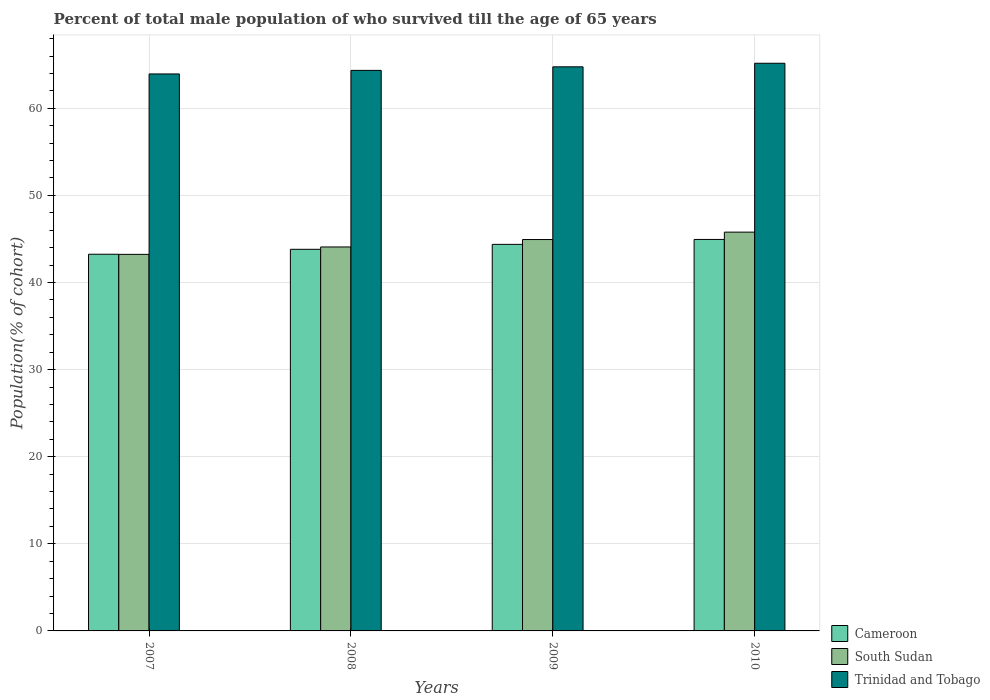Are the number of bars per tick equal to the number of legend labels?
Offer a very short reply. Yes. How many bars are there on the 1st tick from the left?
Offer a very short reply. 3. How many bars are there on the 2nd tick from the right?
Ensure brevity in your answer.  3. What is the label of the 4th group of bars from the left?
Your answer should be compact. 2010. What is the percentage of total male population who survived till the age of 65 years in Cameroon in 2008?
Give a very brief answer. 43.81. Across all years, what is the maximum percentage of total male population who survived till the age of 65 years in South Sudan?
Offer a terse response. 45.78. Across all years, what is the minimum percentage of total male population who survived till the age of 65 years in Cameroon?
Your answer should be very brief. 43.24. In which year was the percentage of total male population who survived till the age of 65 years in Cameroon minimum?
Ensure brevity in your answer.  2007. What is the total percentage of total male population who survived till the age of 65 years in Cameroon in the graph?
Provide a short and direct response. 176.38. What is the difference between the percentage of total male population who survived till the age of 65 years in South Sudan in 2007 and that in 2008?
Provide a succinct answer. -0.85. What is the difference between the percentage of total male population who survived till the age of 65 years in South Sudan in 2008 and the percentage of total male population who survived till the age of 65 years in Cameroon in 2010?
Provide a short and direct response. -0.86. What is the average percentage of total male population who survived till the age of 65 years in Trinidad and Tobago per year?
Your response must be concise. 64.56. In the year 2007, what is the difference between the percentage of total male population who survived till the age of 65 years in Cameroon and percentage of total male population who survived till the age of 65 years in South Sudan?
Offer a very short reply. 0.02. In how many years, is the percentage of total male population who survived till the age of 65 years in South Sudan greater than 36 %?
Ensure brevity in your answer.  4. What is the ratio of the percentage of total male population who survived till the age of 65 years in Trinidad and Tobago in 2008 to that in 2009?
Ensure brevity in your answer.  0.99. Is the difference between the percentage of total male population who survived till the age of 65 years in Cameroon in 2007 and 2008 greater than the difference between the percentage of total male population who survived till the age of 65 years in South Sudan in 2007 and 2008?
Keep it short and to the point. Yes. What is the difference between the highest and the second highest percentage of total male population who survived till the age of 65 years in Cameroon?
Provide a short and direct response. 0.57. What is the difference between the highest and the lowest percentage of total male population who survived till the age of 65 years in Cameroon?
Your answer should be very brief. 1.7. Is the sum of the percentage of total male population who survived till the age of 65 years in Trinidad and Tobago in 2009 and 2010 greater than the maximum percentage of total male population who survived till the age of 65 years in Cameroon across all years?
Make the answer very short. Yes. What does the 3rd bar from the left in 2008 represents?
Keep it short and to the point. Trinidad and Tobago. What does the 1st bar from the right in 2008 represents?
Offer a very short reply. Trinidad and Tobago. Is it the case that in every year, the sum of the percentage of total male population who survived till the age of 65 years in South Sudan and percentage of total male population who survived till the age of 65 years in Trinidad and Tobago is greater than the percentage of total male population who survived till the age of 65 years in Cameroon?
Ensure brevity in your answer.  Yes. How many bars are there?
Make the answer very short. 12. How are the legend labels stacked?
Your answer should be very brief. Vertical. What is the title of the graph?
Ensure brevity in your answer.  Percent of total male population of who survived till the age of 65 years. Does "Panama" appear as one of the legend labels in the graph?
Your response must be concise. No. What is the label or title of the Y-axis?
Offer a very short reply. Population(% of cohort). What is the Population(% of cohort) in Cameroon in 2007?
Provide a short and direct response. 43.24. What is the Population(% of cohort) of South Sudan in 2007?
Provide a short and direct response. 43.23. What is the Population(% of cohort) in Trinidad and Tobago in 2007?
Your answer should be very brief. 63.94. What is the Population(% of cohort) in Cameroon in 2008?
Provide a succinct answer. 43.81. What is the Population(% of cohort) in South Sudan in 2008?
Keep it short and to the point. 44.08. What is the Population(% of cohort) in Trinidad and Tobago in 2008?
Keep it short and to the point. 64.35. What is the Population(% of cohort) in Cameroon in 2009?
Provide a succinct answer. 44.38. What is the Population(% of cohort) of South Sudan in 2009?
Offer a very short reply. 44.93. What is the Population(% of cohort) of Trinidad and Tobago in 2009?
Provide a succinct answer. 64.76. What is the Population(% of cohort) of Cameroon in 2010?
Offer a very short reply. 44.94. What is the Population(% of cohort) of South Sudan in 2010?
Offer a very short reply. 45.78. What is the Population(% of cohort) in Trinidad and Tobago in 2010?
Make the answer very short. 65.17. Across all years, what is the maximum Population(% of cohort) of Cameroon?
Your answer should be compact. 44.94. Across all years, what is the maximum Population(% of cohort) of South Sudan?
Your answer should be very brief. 45.78. Across all years, what is the maximum Population(% of cohort) of Trinidad and Tobago?
Your answer should be very brief. 65.17. Across all years, what is the minimum Population(% of cohort) in Cameroon?
Offer a terse response. 43.24. Across all years, what is the minimum Population(% of cohort) in South Sudan?
Make the answer very short. 43.23. Across all years, what is the minimum Population(% of cohort) in Trinidad and Tobago?
Keep it short and to the point. 63.94. What is the total Population(% of cohort) in Cameroon in the graph?
Make the answer very short. 176.38. What is the total Population(% of cohort) of South Sudan in the graph?
Ensure brevity in your answer.  178.03. What is the total Population(% of cohort) in Trinidad and Tobago in the graph?
Give a very brief answer. 258.23. What is the difference between the Population(% of cohort) in Cameroon in 2007 and that in 2008?
Give a very brief answer. -0.57. What is the difference between the Population(% of cohort) of South Sudan in 2007 and that in 2008?
Offer a terse response. -0.85. What is the difference between the Population(% of cohort) in Trinidad and Tobago in 2007 and that in 2008?
Ensure brevity in your answer.  -0.41. What is the difference between the Population(% of cohort) of Cameroon in 2007 and that in 2009?
Your answer should be very brief. -1.13. What is the difference between the Population(% of cohort) of South Sudan in 2007 and that in 2009?
Your answer should be very brief. -1.7. What is the difference between the Population(% of cohort) in Trinidad and Tobago in 2007 and that in 2009?
Offer a very short reply. -0.82. What is the difference between the Population(% of cohort) in Cameroon in 2007 and that in 2010?
Your answer should be very brief. -1.7. What is the difference between the Population(% of cohort) in South Sudan in 2007 and that in 2010?
Give a very brief answer. -2.55. What is the difference between the Population(% of cohort) of Trinidad and Tobago in 2007 and that in 2010?
Provide a short and direct response. -1.23. What is the difference between the Population(% of cohort) of Cameroon in 2008 and that in 2009?
Provide a short and direct response. -0.57. What is the difference between the Population(% of cohort) of South Sudan in 2008 and that in 2009?
Your answer should be very brief. -0.85. What is the difference between the Population(% of cohort) of Trinidad and Tobago in 2008 and that in 2009?
Provide a short and direct response. -0.41. What is the difference between the Population(% of cohort) of Cameroon in 2008 and that in 2010?
Provide a short and direct response. -1.13. What is the difference between the Population(% of cohort) in South Sudan in 2008 and that in 2010?
Offer a very short reply. -1.7. What is the difference between the Population(% of cohort) in Trinidad and Tobago in 2008 and that in 2010?
Provide a short and direct response. -0.82. What is the difference between the Population(% of cohort) of Cameroon in 2009 and that in 2010?
Ensure brevity in your answer.  -0.57. What is the difference between the Population(% of cohort) of South Sudan in 2009 and that in 2010?
Provide a succinct answer. -0.85. What is the difference between the Population(% of cohort) in Trinidad and Tobago in 2009 and that in 2010?
Provide a short and direct response. -0.41. What is the difference between the Population(% of cohort) in Cameroon in 2007 and the Population(% of cohort) in South Sudan in 2008?
Keep it short and to the point. -0.84. What is the difference between the Population(% of cohort) in Cameroon in 2007 and the Population(% of cohort) in Trinidad and Tobago in 2008?
Offer a terse response. -21.11. What is the difference between the Population(% of cohort) of South Sudan in 2007 and the Population(% of cohort) of Trinidad and Tobago in 2008?
Provide a succinct answer. -21.12. What is the difference between the Population(% of cohort) of Cameroon in 2007 and the Population(% of cohort) of South Sudan in 2009?
Your answer should be very brief. -1.69. What is the difference between the Population(% of cohort) of Cameroon in 2007 and the Population(% of cohort) of Trinidad and Tobago in 2009?
Provide a short and direct response. -21.52. What is the difference between the Population(% of cohort) of South Sudan in 2007 and the Population(% of cohort) of Trinidad and Tobago in 2009?
Provide a succinct answer. -21.53. What is the difference between the Population(% of cohort) of Cameroon in 2007 and the Population(% of cohort) of South Sudan in 2010?
Your response must be concise. -2.54. What is the difference between the Population(% of cohort) of Cameroon in 2007 and the Population(% of cohort) of Trinidad and Tobago in 2010?
Provide a short and direct response. -21.93. What is the difference between the Population(% of cohort) in South Sudan in 2007 and the Population(% of cohort) in Trinidad and Tobago in 2010?
Provide a short and direct response. -21.94. What is the difference between the Population(% of cohort) of Cameroon in 2008 and the Population(% of cohort) of South Sudan in 2009?
Provide a short and direct response. -1.12. What is the difference between the Population(% of cohort) of Cameroon in 2008 and the Population(% of cohort) of Trinidad and Tobago in 2009?
Ensure brevity in your answer.  -20.95. What is the difference between the Population(% of cohort) in South Sudan in 2008 and the Population(% of cohort) in Trinidad and Tobago in 2009?
Give a very brief answer. -20.68. What is the difference between the Population(% of cohort) in Cameroon in 2008 and the Population(% of cohort) in South Sudan in 2010?
Provide a short and direct response. -1.97. What is the difference between the Population(% of cohort) of Cameroon in 2008 and the Population(% of cohort) of Trinidad and Tobago in 2010?
Offer a terse response. -21.36. What is the difference between the Population(% of cohort) of South Sudan in 2008 and the Population(% of cohort) of Trinidad and Tobago in 2010?
Provide a short and direct response. -21.09. What is the difference between the Population(% of cohort) in Cameroon in 2009 and the Population(% of cohort) in South Sudan in 2010?
Give a very brief answer. -1.41. What is the difference between the Population(% of cohort) of Cameroon in 2009 and the Population(% of cohort) of Trinidad and Tobago in 2010?
Offer a terse response. -20.79. What is the difference between the Population(% of cohort) of South Sudan in 2009 and the Population(% of cohort) of Trinidad and Tobago in 2010?
Your answer should be very brief. -20.24. What is the average Population(% of cohort) of Cameroon per year?
Keep it short and to the point. 44.09. What is the average Population(% of cohort) in South Sudan per year?
Your answer should be compact. 44.51. What is the average Population(% of cohort) in Trinidad and Tobago per year?
Provide a short and direct response. 64.56. In the year 2007, what is the difference between the Population(% of cohort) of Cameroon and Population(% of cohort) of South Sudan?
Keep it short and to the point. 0.02. In the year 2007, what is the difference between the Population(% of cohort) of Cameroon and Population(% of cohort) of Trinidad and Tobago?
Offer a very short reply. -20.7. In the year 2007, what is the difference between the Population(% of cohort) of South Sudan and Population(% of cohort) of Trinidad and Tobago?
Provide a succinct answer. -20.71. In the year 2008, what is the difference between the Population(% of cohort) of Cameroon and Population(% of cohort) of South Sudan?
Your answer should be compact. -0.27. In the year 2008, what is the difference between the Population(% of cohort) in Cameroon and Population(% of cohort) in Trinidad and Tobago?
Your answer should be compact. -20.54. In the year 2008, what is the difference between the Population(% of cohort) in South Sudan and Population(% of cohort) in Trinidad and Tobago?
Offer a terse response. -20.27. In the year 2009, what is the difference between the Population(% of cohort) of Cameroon and Population(% of cohort) of South Sudan?
Keep it short and to the point. -0.55. In the year 2009, what is the difference between the Population(% of cohort) of Cameroon and Population(% of cohort) of Trinidad and Tobago?
Provide a succinct answer. -20.38. In the year 2009, what is the difference between the Population(% of cohort) in South Sudan and Population(% of cohort) in Trinidad and Tobago?
Give a very brief answer. -19.83. In the year 2010, what is the difference between the Population(% of cohort) in Cameroon and Population(% of cohort) in South Sudan?
Provide a succinct answer. -0.84. In the year 2010, what is the difference between the Population(% of cohort) in Cameroon and Population(% of cohort) in Trinidad and Tobago?
Your response must be concise. -20.23. In the year 2010, what is the difference between the Population(% of cohort) of South Sudan and Population(% of cohort) of Trinidad and Tobago?
Ensure brevity in your answer.  -19.39. What is the ratio of the Population(% of cohort) of Cameroon in 2007 to that in 2008?
Ensure brevity in your answer.  0.99. What is the ratio of the Population(% of cohort) in South Sudan in 2007 to that in 2008?
Give a very brief answer. 0.98. What is the ratio of the Population(% of cohort) in Cameroon in 2007 to that in 2009?
Your response must be concise. 0.97. What is the ratio of the Population(% of cohort) of South Sudan in 2007 to that in 2009?
Make the answer very short. 0.96. What is the ratio of the Population(% of cohort) of Trinidad and Tobago in 2007 to that in 2009?
Provide a short and direct response. 0.99. What is the ratio of the Population(% of cohort) of Cameroon in 2007 to that in 2010?
Give a very brief answer. 0.96. What is the ratio of the Population(% of cohort) of South Sudan in 2007 to that in 2010?
Your answer should be compact. 0.94. What is the ratio of the Population(% of cohort) of Trinidad and Tobago in 2007 to that in 2010?
Your response must be concise. 0.98. What is the ratio of the Population(% of cohort) of Cameroon in 2008 to that in 2009?
Offer a terse response. 0.99. What is the ratio of the Population(% of cohort) in South Sudan in 2008 to that in 2009?
Your response must be concise. 0.98. What is the ratio of the Population(% of cohort) in Cameroon in 2008 to that in 2010?
Make the answer very short. 0.97. What is the ratio of the Population(% of cohort) of South Sudan in 2008 to that in 2010?
Keep it short and to the point. 0.96. What is the ratio of the Population(% of cohort) of Trinidad and Tobago in 2008 to that in 2010?
Ensure brevity in your answer.  0.99. What is the ratio of the Population(% of cohort) of Cameroon in 2009 to that in 2010?
Offer a terse response. 0.99. What is the ratio of the Population(% of cohort) of South Sudan in 2009 to that in 2010?
Your answer should be compact. 0.98. What is the difference between the highest and the second highest Population(% of cohort) of Cameroon?
Your answer should be compact. 0.57. What is the difference between the highest and the second highest Population(% of cohort) of South Sudan?
Ensure brevity in your answer.  0.85. What is the difference between the highest and the second highest Population(% of cohort) in Trinidad and Tobago?
Make the answer very short. 0.41. What is the difference between the highest and the lowest Population(% of cohort) of Cameroon?
Your answer should be very brief. 1.7. What is the difference between the highest and the lowest Population(% of cohort) of South Sudan?
Offer a terse response. 2.55. What is the difference between the highest and the lowest Population(% of cohort) in Trinidad and Tobago?
Offer a terse response. 1.23. 